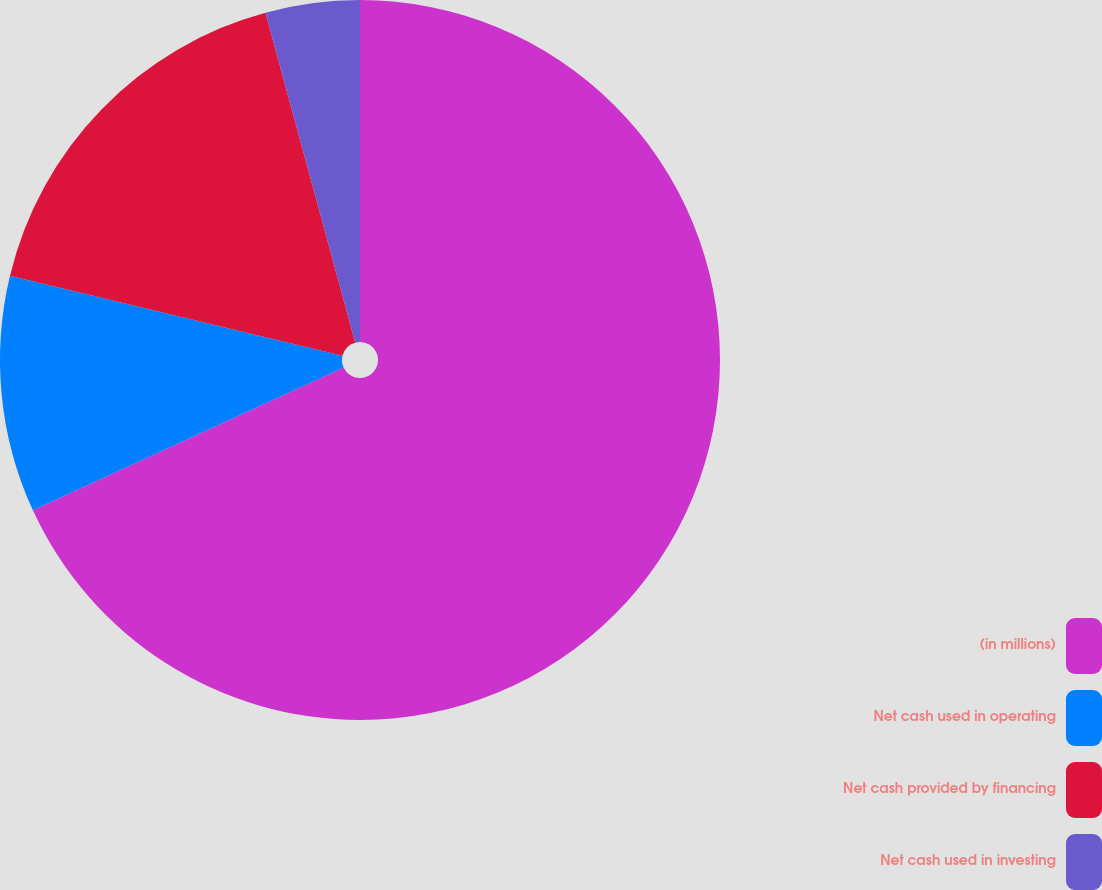Convert chart to OTSL. <chart><loc_0><loc_0><loc_500><loc_500><pie_chart><fcel>(in millions)<fcel>Net cash used in operating<fcel>Net cash provided by financing<fcel>Net cash used in investing<nl><fcel>68.15%<fcel>10.62%<fcel>17.01%<fcel>4.23%<nl></chart> 